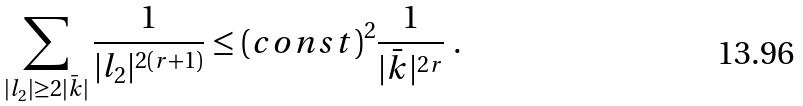Convert formula to latex. <formula><loc_0><loc_0><loc_500><loc_500>\sum _ { | l _ { 2 } | \geq 2 | \bar { k } | } \frac { 1 } { | l _ { 2 } | ^ { 2 ( r + 1 ) } } \leq ( c o n s t ) ^ { 2 } \frac { 1 } { | \bar { k } | ^ { 2 r } } \ .</formula> 